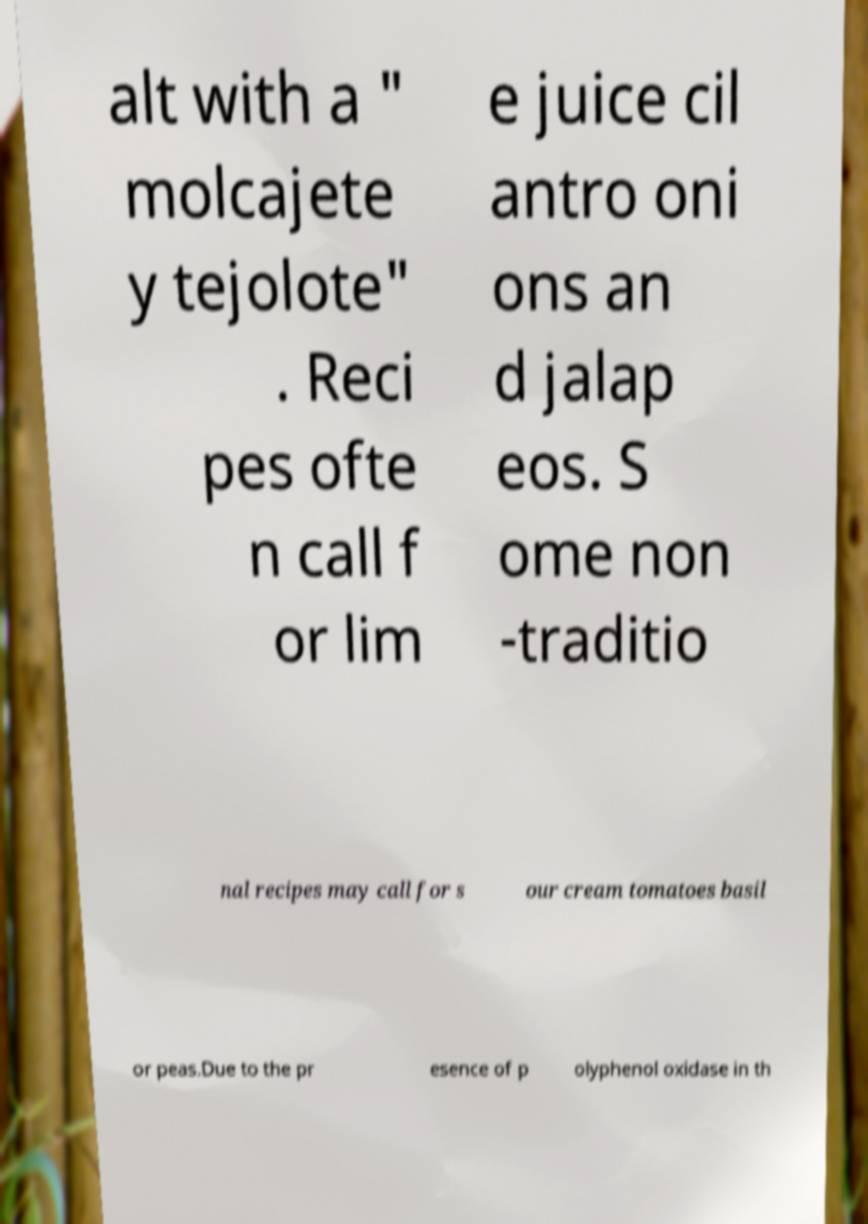Please identify and transcribe the text found in this image. alt with a " molcajete y tejolote" . Reci pes ofte n call f or lim e juice cil antro oni ons an d jalap eos. S ome non -traditio nal recipes may call for s our cream tomatoes basil or peas.Due to the pr esence of p olyphenol oxidase in th 